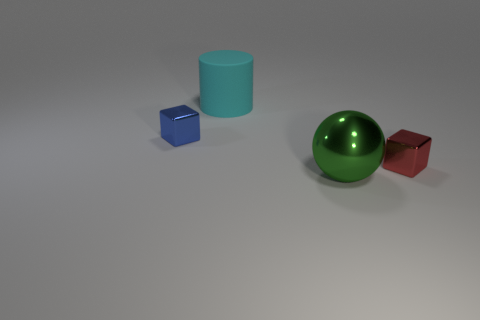Add 2 gray rubber cylinders. How many objects exist? 6 Subtract all cylinders. How many objects are left? 3 Subtract all small cyan metallic objects. Subtract all large green balls. How many objects are left? 3 Add 1 big green objects. How many big green objects are left? 2 Add 3 metal cubes. How many metal cubes exist? 5 Subtract 0 green cylinders. How many objects are left? 4 